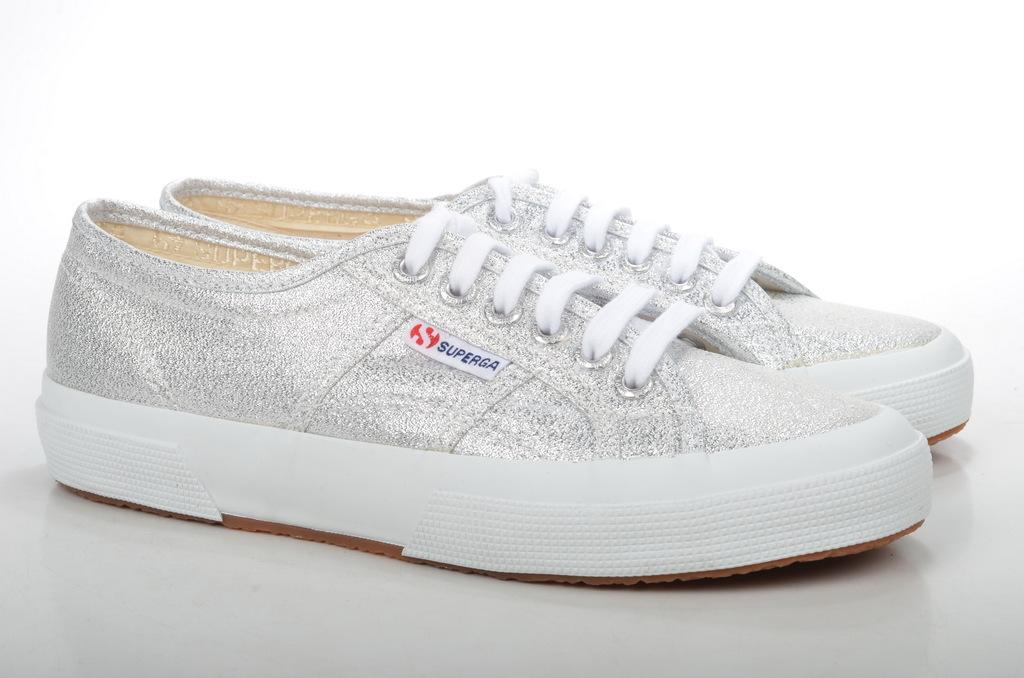What type of footwear is visible in the image? There are shoes in the image. Where are the shoes placed? The shoes are on a white color platform. What type of destruction can be seen happening to the coast in the image? There is no mention of destruction or a coast in the image; it only features shoes on a white platform. 